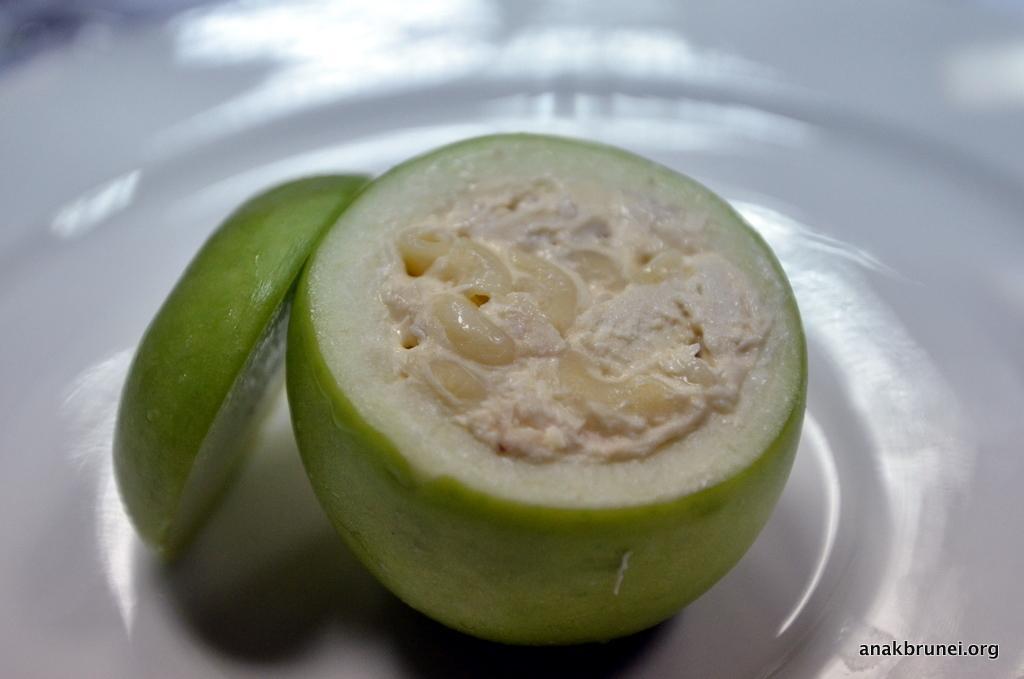Could you give a brief overview of what you see in this image? This image contains a plate having a fruit on it. Inside fruit there is some food stuffed in it. Beside it there is a slice of the fruit on plate. 